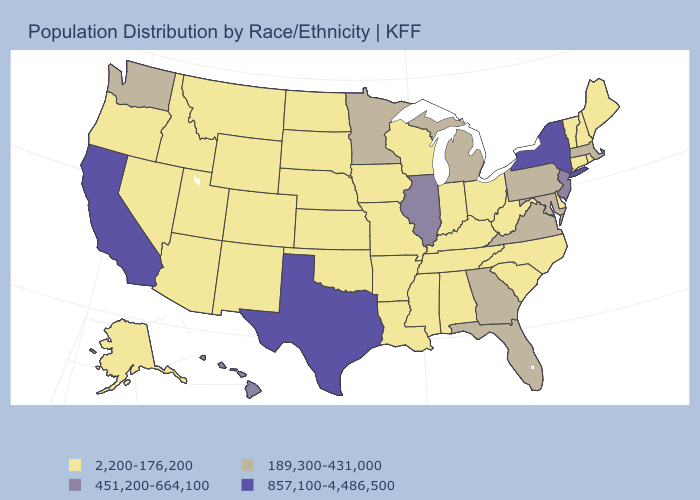Name the states that have a value in the range 2,200-176,200?
Quick response, please. Alabama, Alaska, Arizona, Arkansas, Colorado, Connecticut, Delaware, Idaho, Indiana, Iowa, Kansas, Kentucky, Louisiana, Maine, Mississippi, Missouri, Montana, Nebraska, Nevada, New Hampshire, New Mexico, North Carolina, North Dakota, Ohio, Oklahoma, Oregon, Rhode Island, South Carolina, South Dakota, Tennessee, Utah, Vermont, West Virginia, Wisconsin, Wyoming. Which states have the highest value in the USA?
Short answer required. California, New York, Texas. Which states have the lowest value in the Northeast?
Write a very short answer. Connecticut, Maine, New Hampshire, Rhode Island, Vermont. Name the states that have a value in the range 451,200-664,100?
Answer briefly. Hawaii, Illinois, New Jersey. What is the value of Montana?
Be succinct. 2,200-176,200. What is the value of Florida?
Write a very short answer. 189,300-431,000. What is the lowest value in the MidWest?
Short answer required. 2,200-176,200. Which states have the highest value in the USA?
Concise answer only. California, New York, Texas. What is the highest value in the USA?
Give a very brief answer. 857,100-4,486,500. Among the states that border Oklahoma , which have the highest value?
Quick response, please. Texas. What is the highest value in the West ?
Quick response, please. 857,100-4,486,500. What is the value of New York?
Concise answer only. 857,100-4,486,500. How many symbols are there in the legend?
Concise answer only. 4. Which states have the lowest value in the USA?
Give a very brief answer. Alabama, Alaska, Arizona, Arkansas, Colorado, Connecticut, Delaware, Idaho, Indiana, Iowa, Kansas, Kentucky, Louisiana, Maine, Mississippi, Missouri, Montana, Nebraska, Nevada, New Hampshire, New Mexico, North Carolina, North Dakota, Ohio, Oklahoma, Oregon, Rhode Island, South Carolina, South Dakota, Tennessee, Utah, Vermont, West Virginia, Wisconsin, Wyoming. Name the states that have a value in the range 2,200-176,200?
Quick response, please. Alabama, Alaska, Arizona, Arkansas, Colorado, Connecticut, Delaware, Idaho, Indiana, Iowa, Kansas, Kentucky, Louisiana, Maine, Mississippi, Missouri, Montana, Nebraska, Nevada, New Hampshire, New Mexico, North Carolina, North Dakota, Ohio, Oklahoma, Oregon, Rhode Island, South Carolina, South Dakota, Tennessee, Utah, Vermont, West Virginia, Wisconsin, Wyoming. 